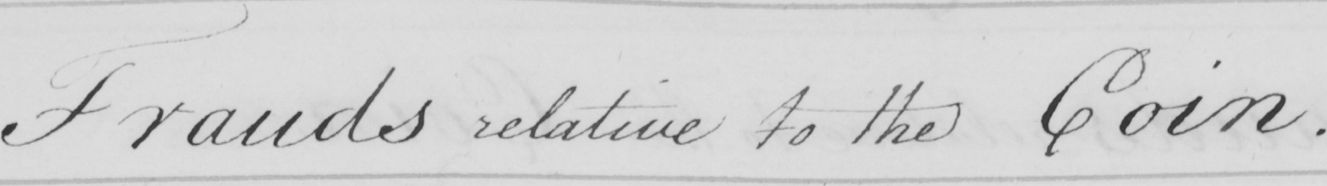Please provide the text content of this handwritten line. Frauds relative to the Coin . 